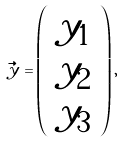<formula> <loc_0><loc_0><loc_500><loc_500>\vec { y } = \left ( \begin{array} { c } y _ { 1 } \\ y _ { 2 } \\ y _ { 3 } \end{array} \right ) ,</formula> 